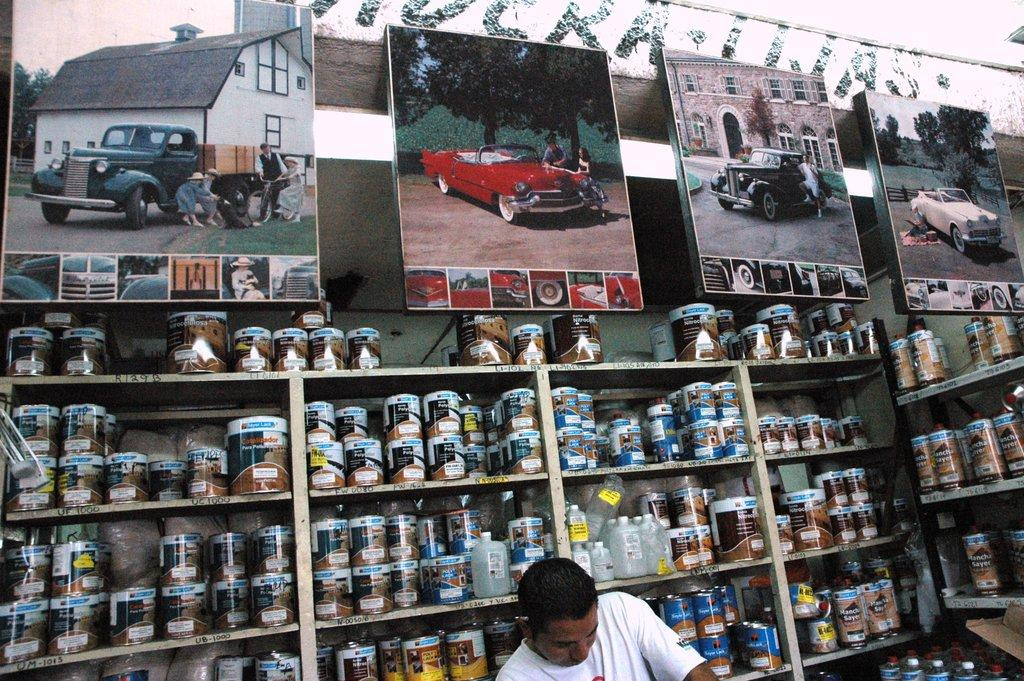Who or what is present in the image? There is a person in the image. What can be seen in the background of the image? There are racks with bottles in the background. What other objects are visible in the image? There are photo frames in the image. What types of images are in the photo frames? The photo frames contain images of vehicles, people, buildings, and trees. What type of plantation can be seen in the image? There is no plantation present in the image. Can you describe the downtown area visible in the image? There is no downtown area visible in the image. 